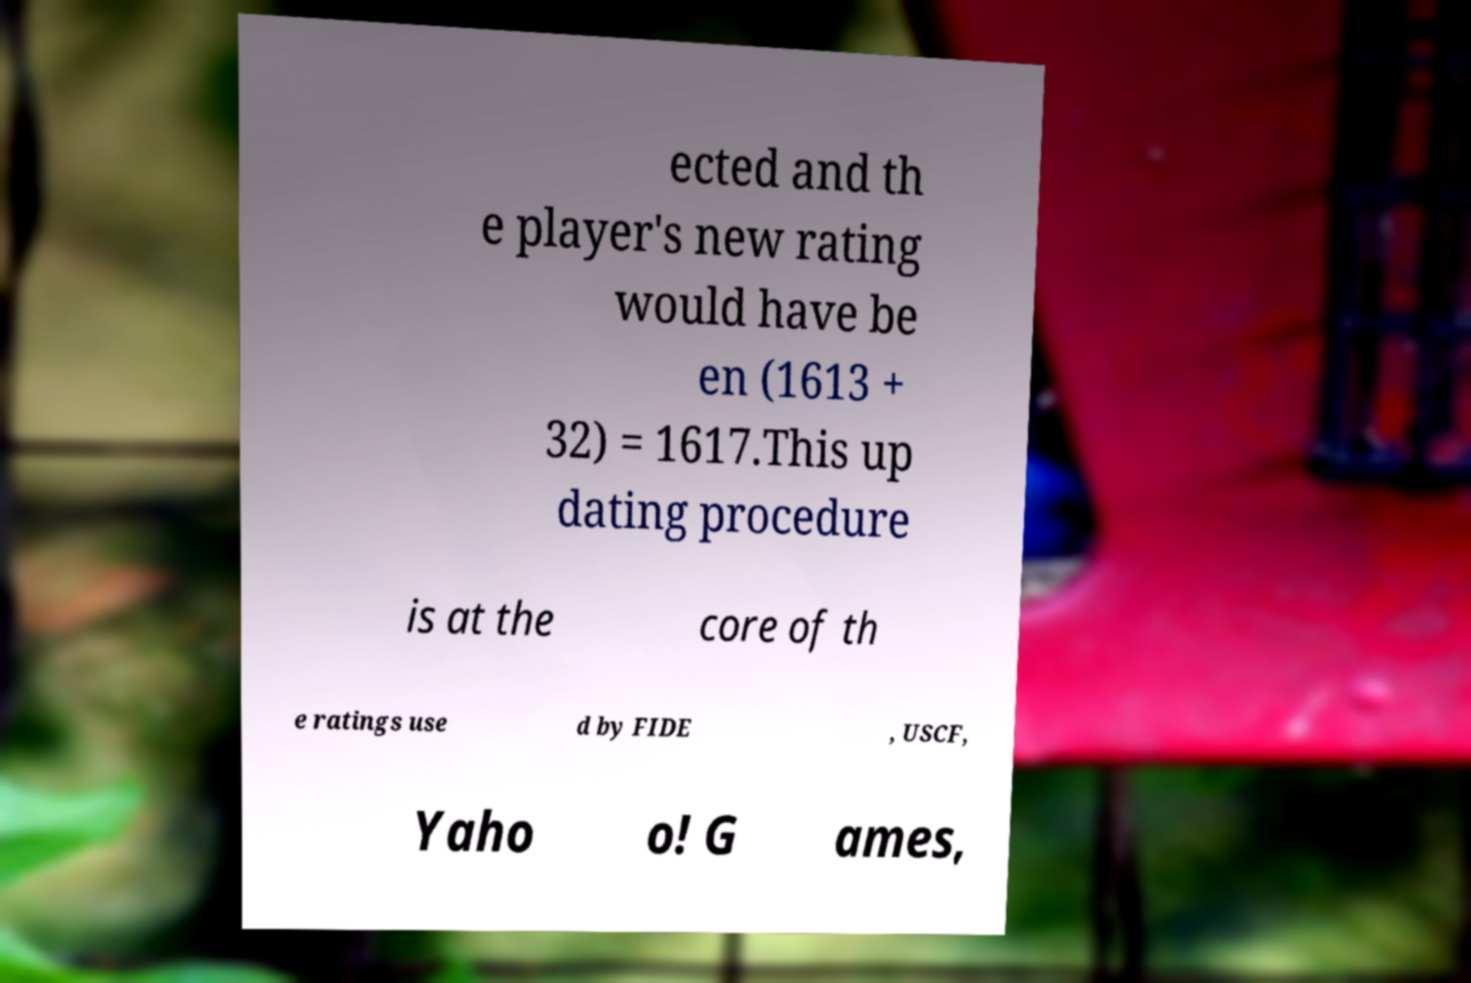Please read and relay the text visible in this image. What does it say? ected and th e player's new rating would have be en (1613 + 32) = 1617.This up dating procedure is at the core of th e ratings use d by FIDE , USCF, Yaho o! G ames, 